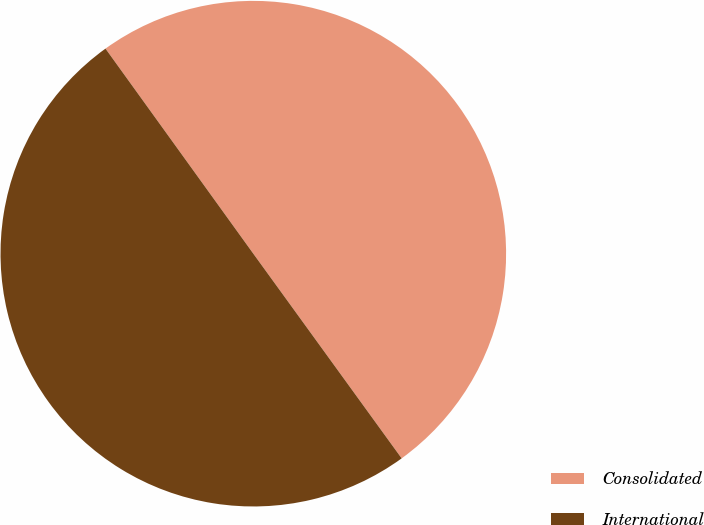Convert chart to OTSL. <chart><loc_0><loc_0><loc_500><loc_500><pie_chart><fcel>Consolidated<fcel>International<nl><fcel>49.96%<fcel>50.04%<nl></chart> 